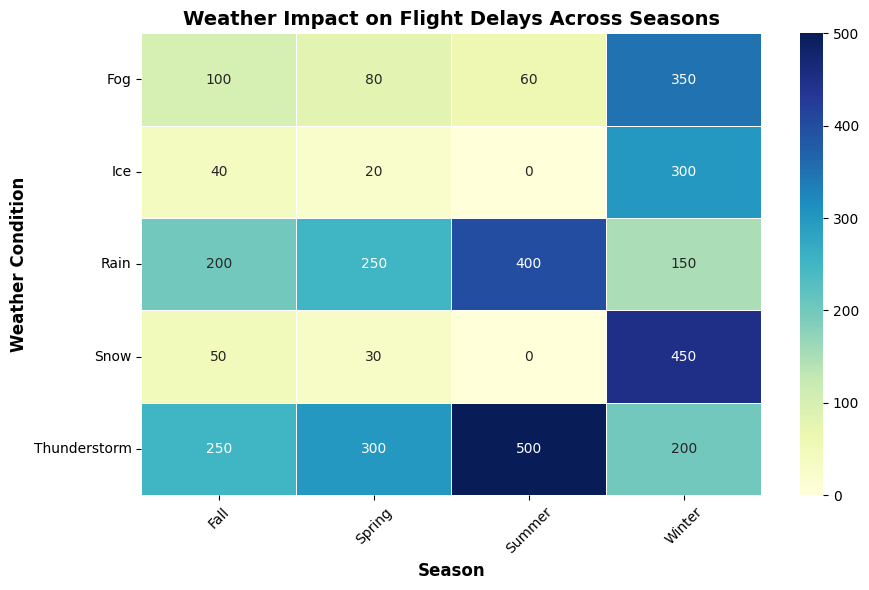Which season experiences the highest number of flight delays due to thunderstorms? First, locate the "Thunderstorm" row in the heatmap. Then, compare the flight delays for each season in this row. Summer has the highest value in this row.
Answer: Summer Which weather condition in Winter causes the most flight delays? Identify and compare the flight delays for each weather condition in the Winter column. Snow has the highest value in this column.
Answer: Snow What is the total number of flight delays caused by fog in all seasons? Sum the flight delays for fog across all seasons: Winter (350) + Spring (80) + Summer (60) + Fall (100) = 590.
Answer: 590 How do flight cancellations caused by rain compare between Summer and Fall? Compare the values in the Rain row for Summer and Fall. Summer has 100 cancellations, and Fall has 40 cancellations. Summer has more cancellations than Fall.
Answer: Summer > Fall Which season has the least impact on flight delays due to snow? Identify and compare the flight delays caused by snow across all seasons. Summer has 0 delays, which is the least.
Answer: Summer Are there any weather conditions that don’t cause any flight delays in any season? Check each weather condition row to see if any values are 0 across all seasons. Both Snow and Ice have zeros, but Ice has 0 delays in Summer only. Snow has 0 in Summer only.
Answer: No, all conditions cause delays in at least one season What is the average number of flight delays due to thunderstorms across all seasons? Sum the flight delays due to thunderstorms for all seasons and divide by the number of seasons: (Winter 200 + Spring 300 + Summer 500 + Fall 250) / 4 = 1250 / 4 = 312.5.
Answer: 312.5 Which weather condition in Spring results in more flight delays, Ice or Rain? Compare the values for Ice and Rain in the Spring column. Ice causes 20 delays, and Rain causes 250 delays. Rain has more delays than Ice.
Answer: Rain In which season does fog have the least impact on flight delays? Compare the flight delays due to fog across all seasons. Summer has the least impact with 60 delays.
Answer: Summer How many more flight delays does Winter have due to snow compared to thunderstorms? Subtract the number of flight delays in Winter caused by thunderstorms from those caused by snow: 450 (Snow) - 200 (Thunderstorm) = 250.
Answer: 250 